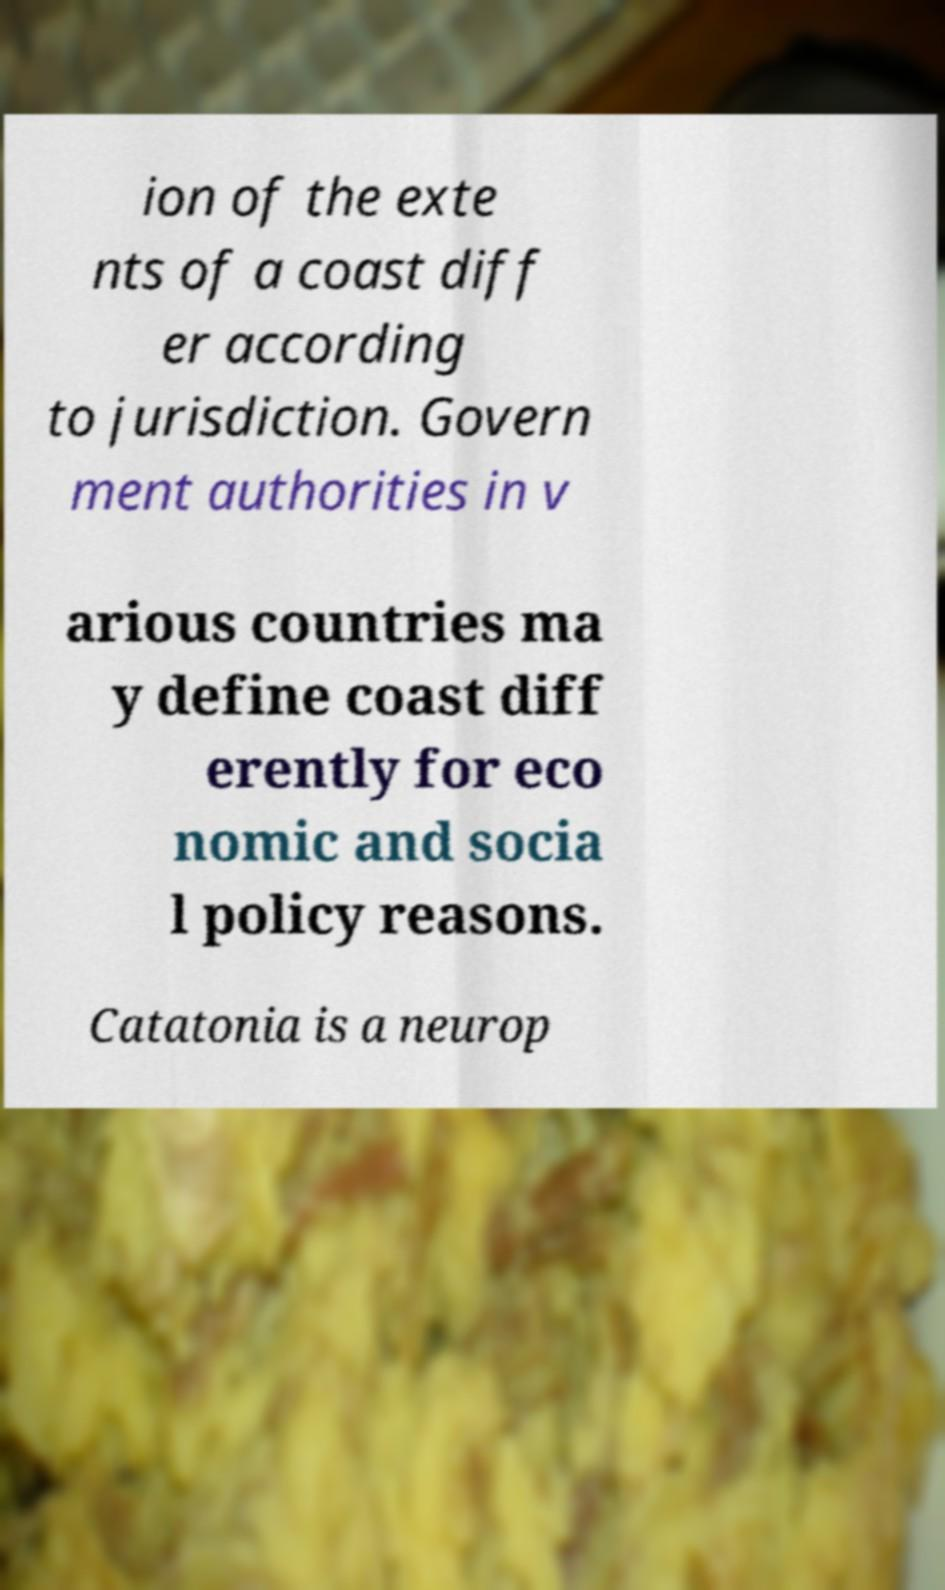Can you read and provide the text displayed in the image?This photo seems to have some interesting text. Can you extract and type it out for me? ion of the exte nts of a coast diff er according to jurisdiction. Govern ment authorities in v arious countries ma y define coast diff erently for eco nomic and socia l policy reasons. Catatonia is a neurop 